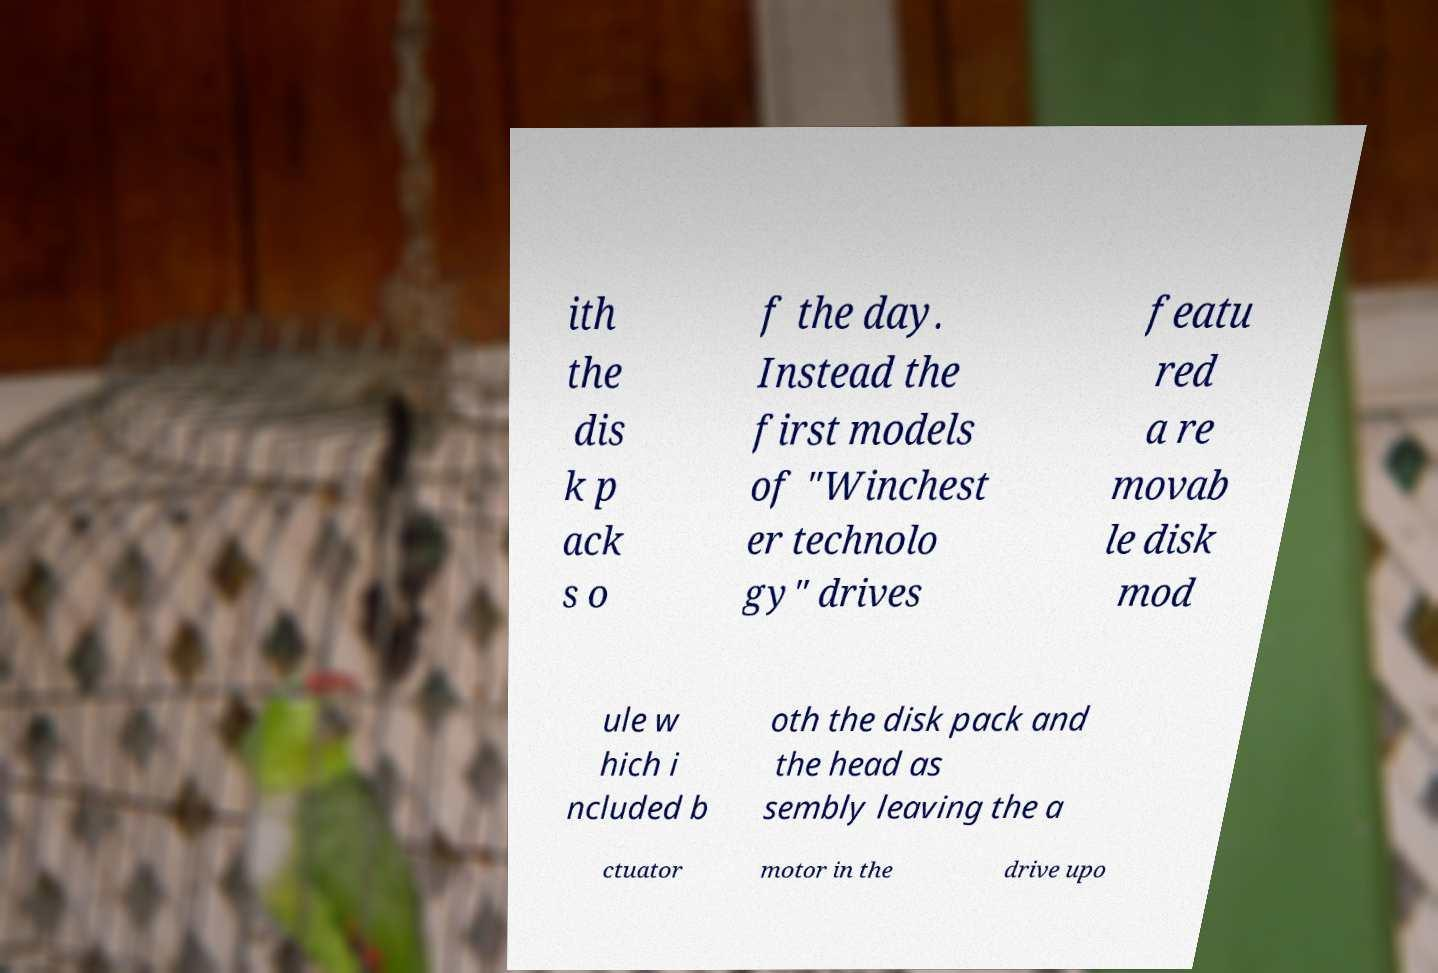There's text embedded in this image that I need extracted. Can you transcribe it verbatim? ith the dis k p ack s o f the day. Instead the first models of "Winchest er technolo gy" drives featu red a re movab le disk mod ule w hich i ncluded b oth the disk pack and the head as sembly leaving the a ctuator motor in the drive upo 